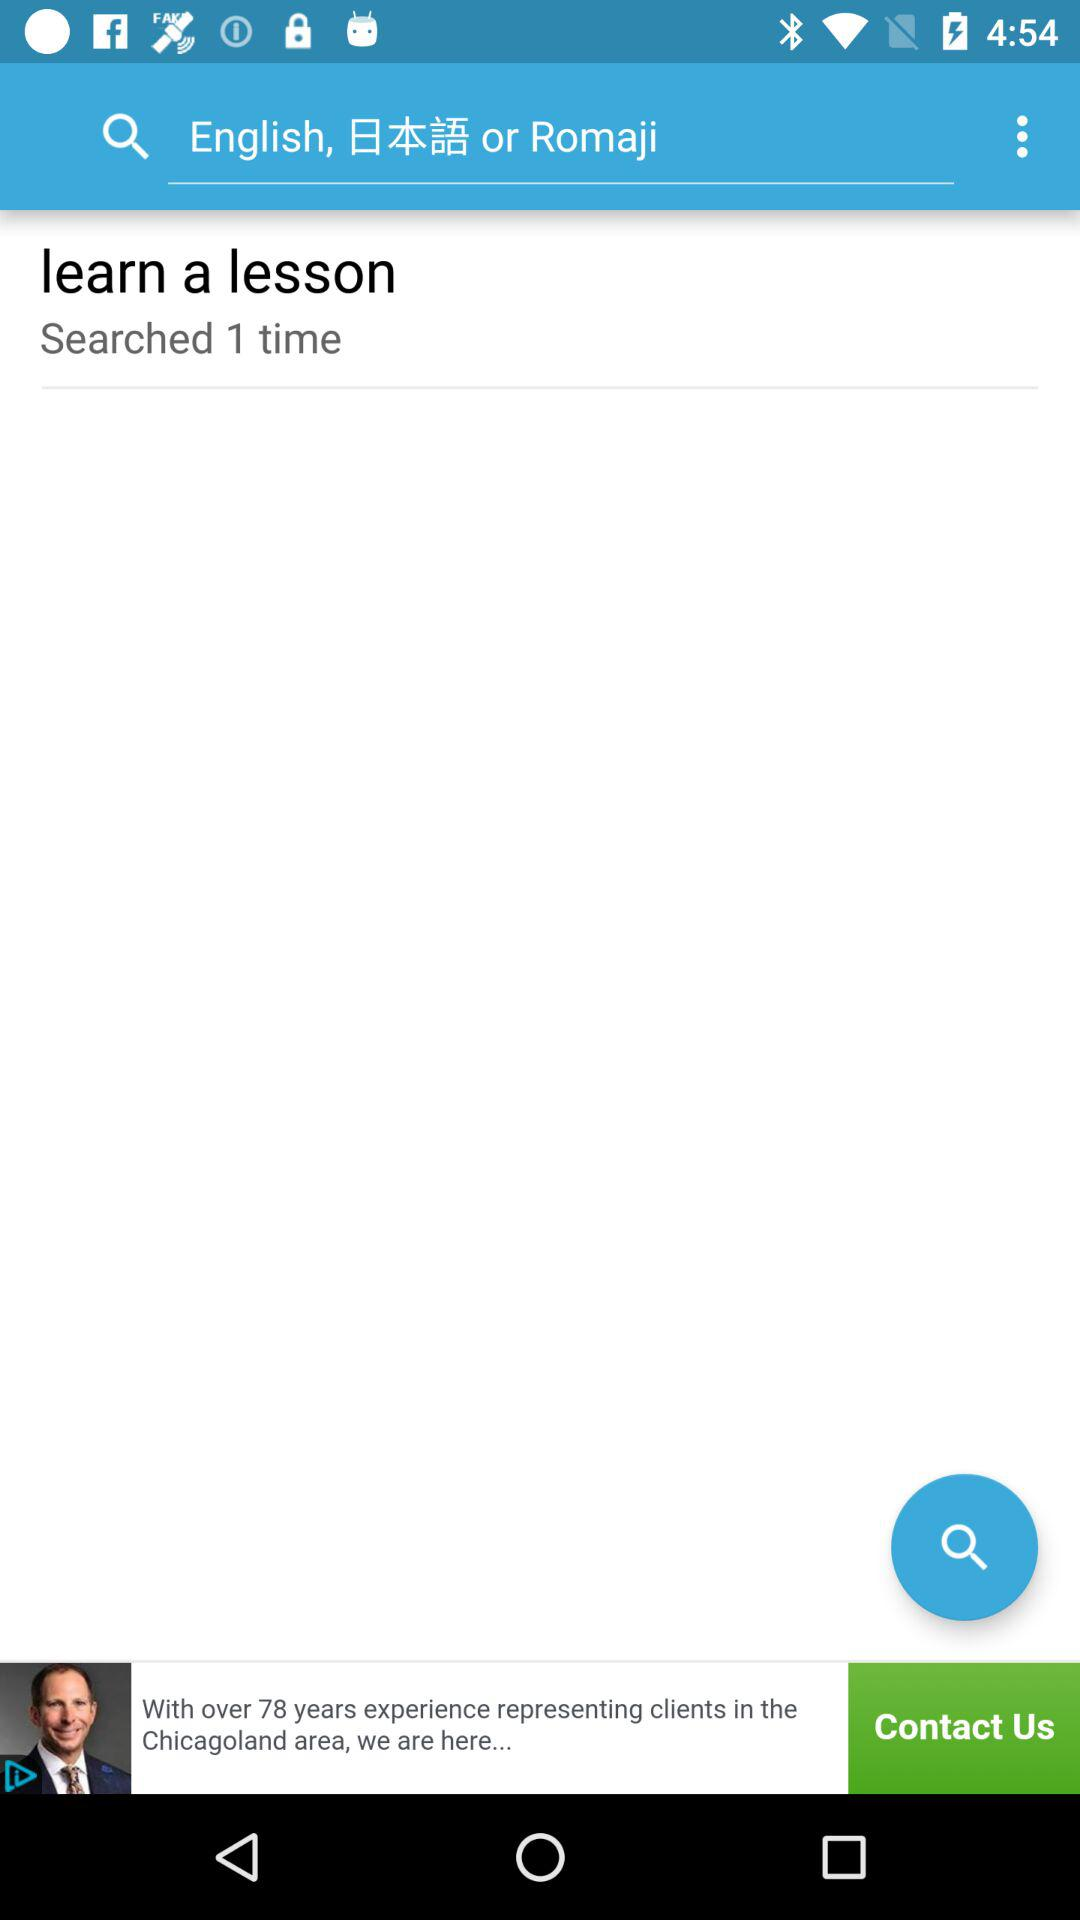How long does it take to learn a lesson?
When the provided information is insufficient, respond with <no answer>. <no answer> 